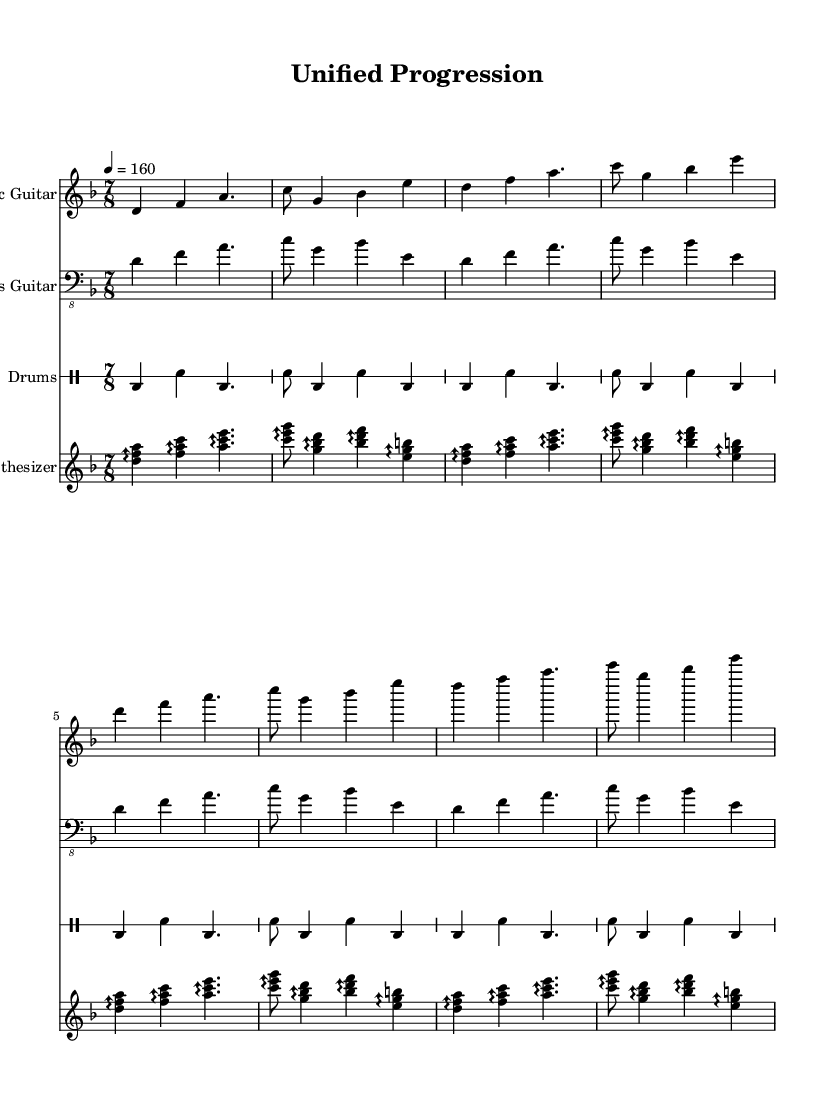What is the key signature of this music? The key signature is D minor, which has one flat (B flat). This can be identified in the relevant section at the beginning of the sheet music, where the key signature glyphs are displayed.
Answer: D minor What is the time signature of this music? The time signature is seven-eight, indicated by the notation at the beginning of the score. It shows there are seven eighth-note beats in each measure.
Answer: 7/8 What is the tempo marking of this track? The tempo marking indicates 160 beats per minute, which is denoted by "4 = 160" in the score. This number shows how many quarter notes or beats are played in one minute.
Answer: 160 How many measures are each of the instruments playing? Each instrument plays for four measures, as indicated in the repeated section of the music, where each part is aligned accordingly across the score.
Answer: 4 What is the most frequently used note in the synthesizer part? The synthesizer part prominently features the note D, which is played across multiple arpeggios throughout the entire section. This can be observed by looking at the repeated patterns that always include D.
Answer: D What is the rhythmic feel of the drum part? The drum part is characterized by a combination of bass and snare hits, creating a driving rhythm typical of metal music. The pattern consists of strong beats in a repetitive style focused on accentuating 4 beats in a measure.
Answer: Driving rhythm Which instrument is playing the melody in this piece? The electric guitar is playing the melody, as its line showcases the lead notes and is designated as the primary melodic instrument in the score above the others.
Answer: Electric Guitar 